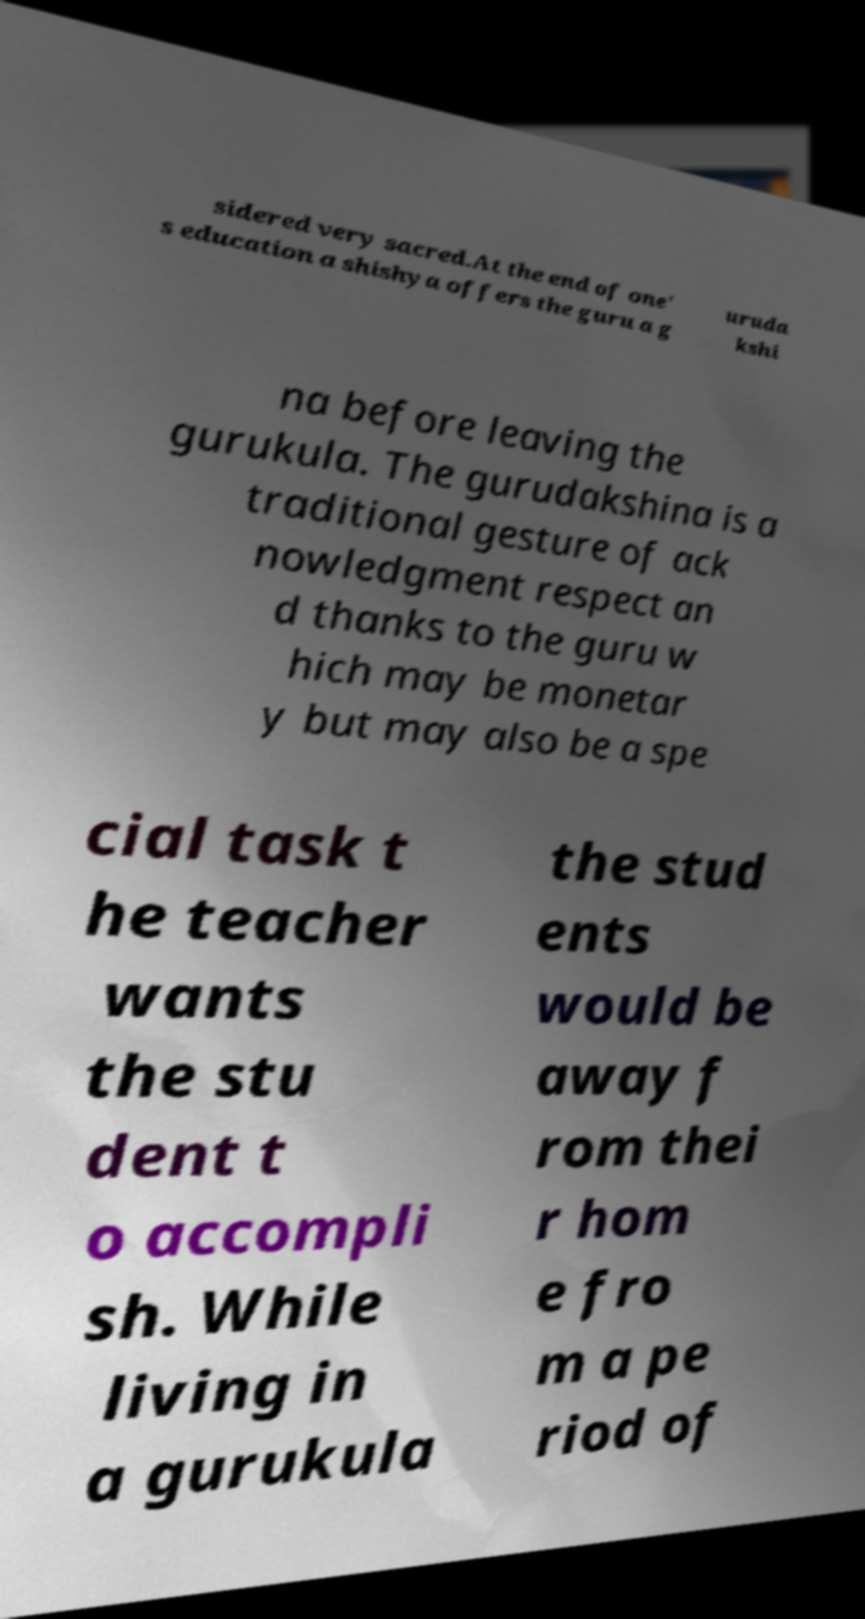Could you extract and type out the text from this image? sidered very sacred.At the end of one' s education a shishya offers the guru a g uruda kshi na before leaving the gurukula. The gurudakshina is a traditional gesture of ack nowledgment respect an d thanks to the guru w hich may be monetar y but may also be a spe cial task t he teacher wants the stu dent t o accompli sh. While living in a gurukula the stud ents would be away f rom thei r hom e fro m a pe riod of 